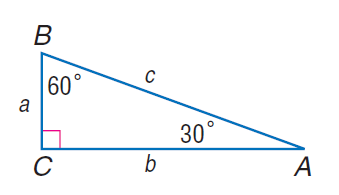Answer the mathemtical geometry problem and directly provide the correct option letter.
Question: If c = 8, find a.
Choices: A: 4 B: 4 \sqrt { 3 } C: 8 D: 8 \sqrt { 3 } A 